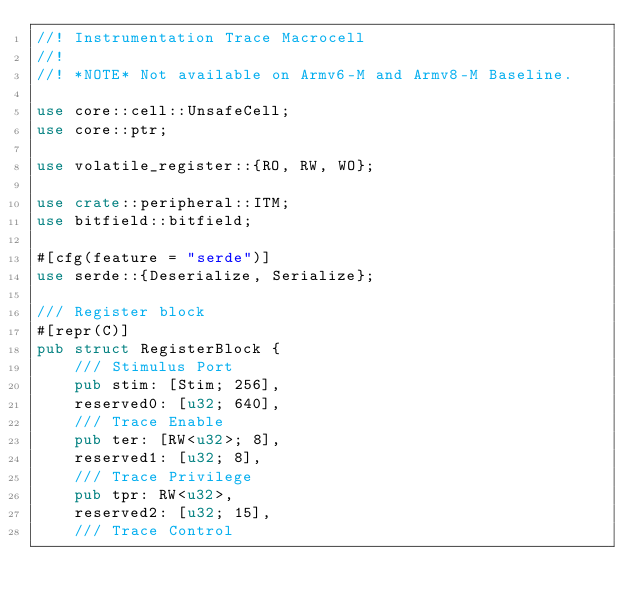Convert code to text. <code><loc_0><loc_0><loc_500><loc_500><_Rust_>//! Instrumentation Trace Macrocell
//!
//! *NOTE* Not available on Armv6-M and Armv8-M Baseline.

use core::cell::UnsafeCell;
use core::ptr;

use volatile_register::{RO, RW, WO};

use crate::peripheral::ITM;
use bitfield::bitfield;

#[cfg(feature = "serde")]
use serde::{Deserialize, Serialize};

/// Register block
#[repr(C)]
pub struct RegisterBlock {
    /// Stimulus Port
    pub stim: [Stim; 256],
    reserved0: [u32; 640],
    /// Trace Enable
    pub ter: [RW<u32>; 8],
    reserved1: [u32; 8],
    /// Trace Privilege
    pub tpr: RW<u32>,
    reserved2: [u32; 15],
    /// Trace Control</code> 